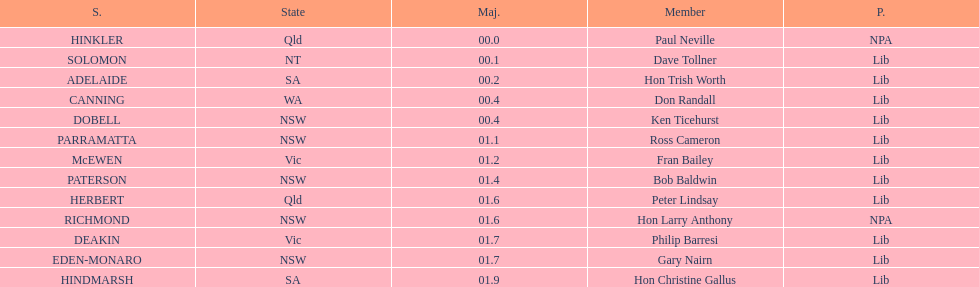How many members are there altogether? 13. Could you parse the entire table as a dict? {'header': ['S.', 'State', 'Maj.', 'Member', 'P.'], 'rows': [['HINKLER', 'Qld', '00.0', 'Paul Neville', 'NPA'], ['SOLOMON', 'NT', '00.1', 'Dave Tollner', 'Lib'], ['ADELAIDE', 'SA', '00.2', 'Hon Trish Worth', 'Lib'], ['CANNING', 'WA', '00.4', 'Don Randall', 'Lib'], ['DOBELL', 'NSW', '00.4', 'Ken Ticehurst', 'Lib'], ['PARRAMATTA', 'NSW', '01.1', 'Ross Cameron', 'Lib'], ['McEWEN', 'Vic', '01.2', 'Fran Bailey', 'Lib'], ['PATERSON', 'NSW', '01.4', 'Bob Baldwin', 'Lib'], ['HERBERT', 'Qld', '01.6', 'Peter Lindsay', 'Lib'], ['RICHMOND', 'NSW', '01.6', 'Hon Larry Anthony', 'NPA'], ['DEAKIN', 'Vic', '01.7', 'Philip Barresi', 'Lib'], ['EDEN-MONARO', 'NSW', '01.7', 'Gary Nairn', 'Lib'], ['HINDMARSH', 'SA', '01.9', 'Hon Christine Gallus', 'Lib']]} 